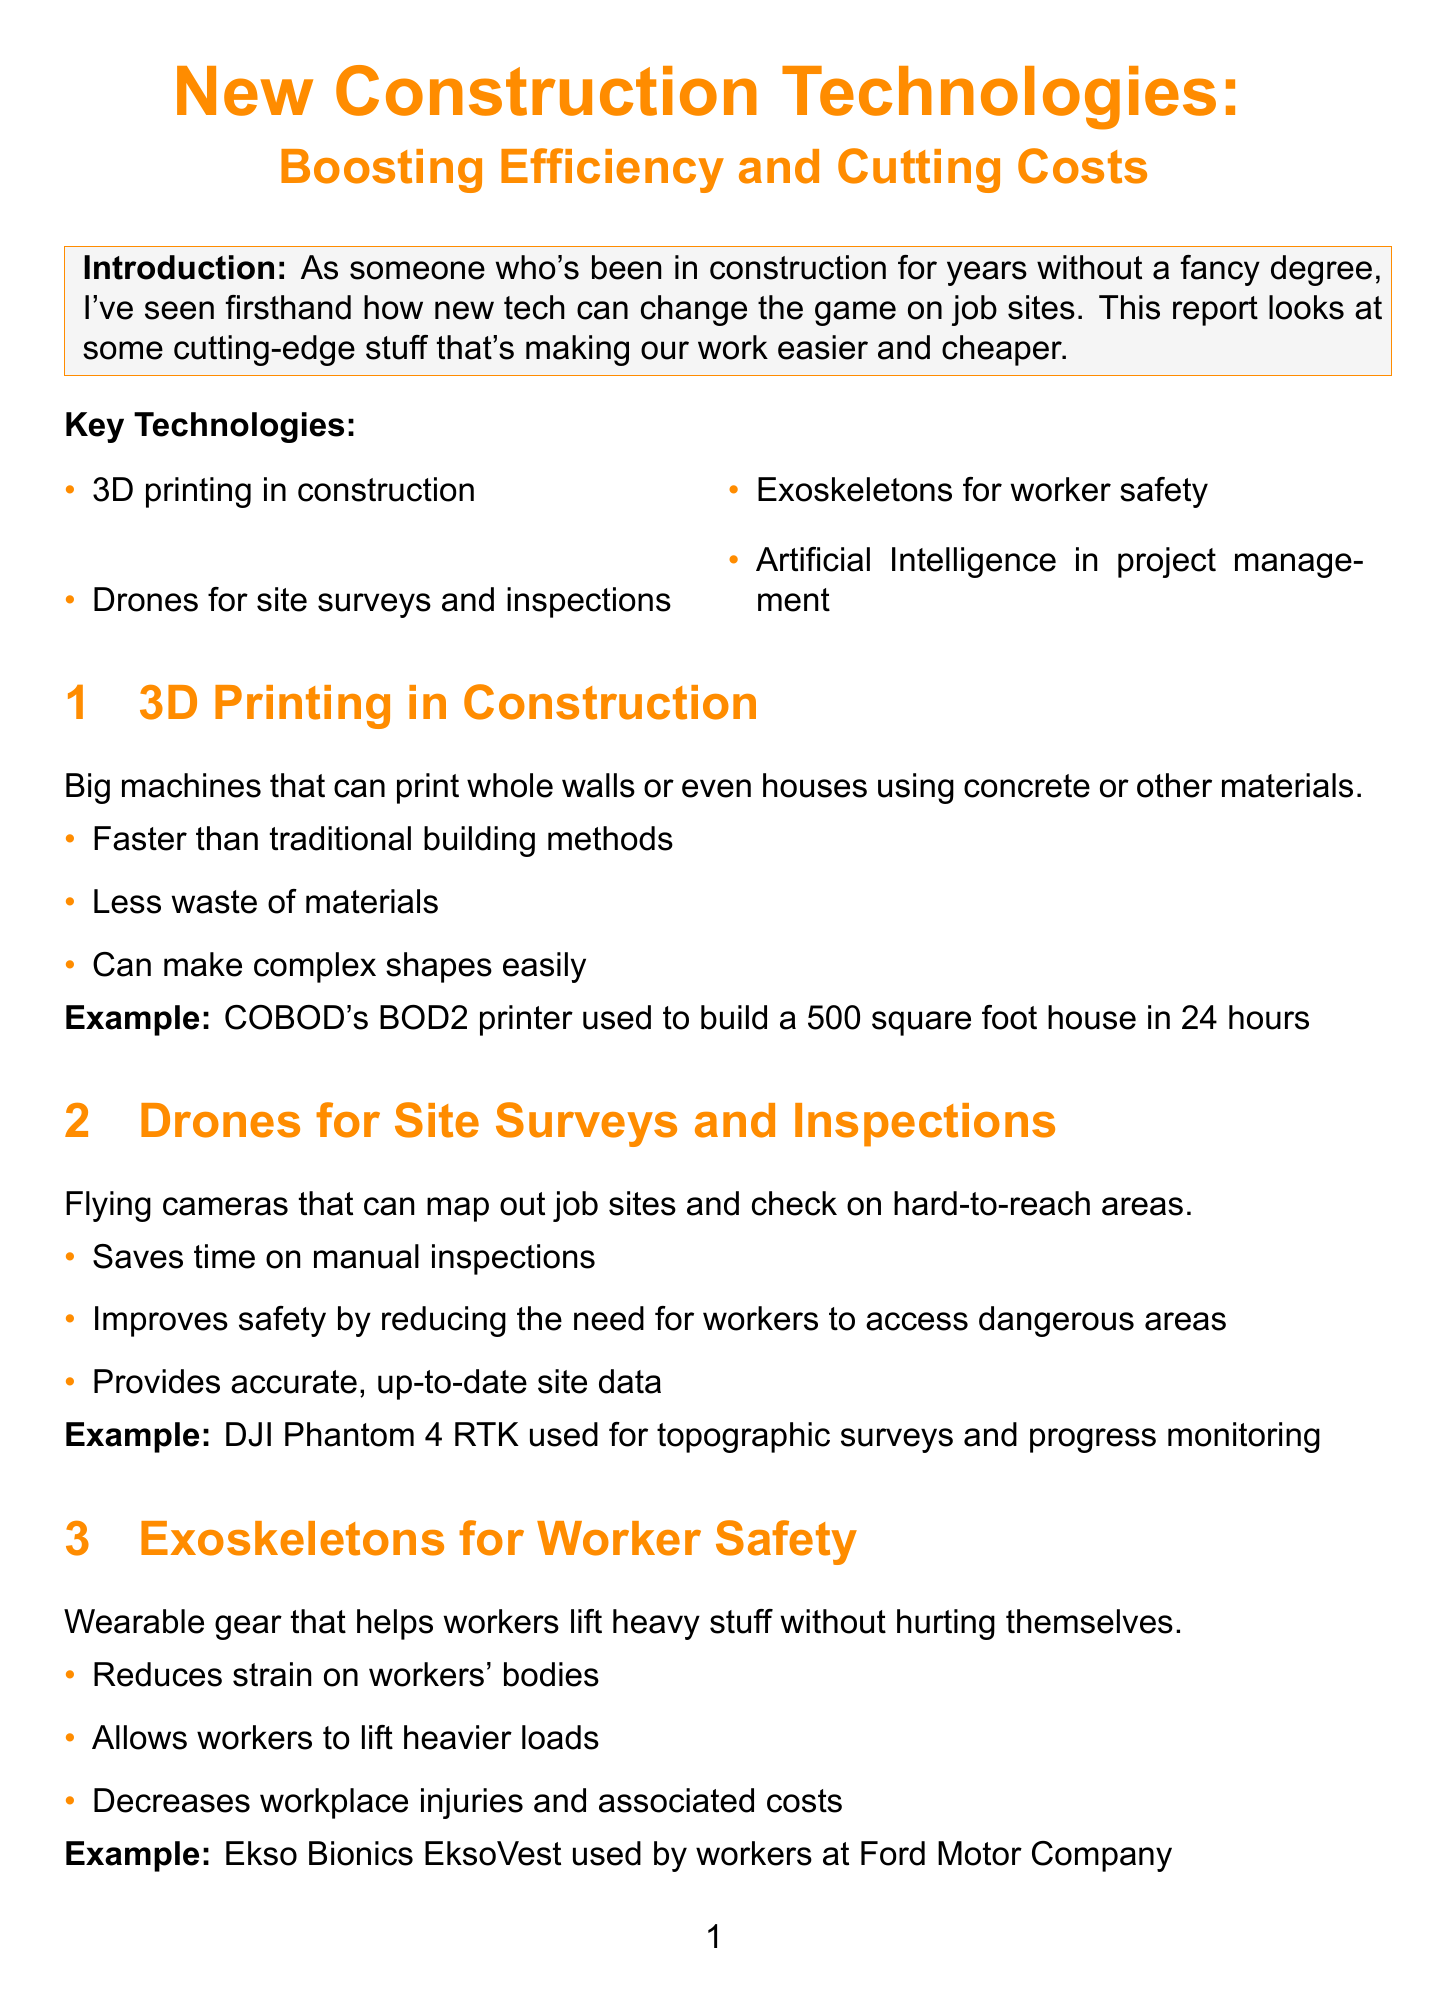What are the key points discussed in the report? The report lists four key points: 3D printing in construction, drones for site surveys and inspections, exoskeletons for worker safety, and artificial intelligence in project management.
Answer: 3D printing in construction; drones for site surveys and inspections; exoskeletons for worker safety; artificial intelligence in project management What technology can cut labor needs by up to 30%? The report states that the technologies discussed can cut labor needs on projects by up to 30%.
Answer: Technologies What is one benefit of using drones on job sites? The document mentions that drones improve safety by reducing the need for workers to access dangerous areas.
Answer: Improves safety What is the example given for 3D printing technology? The report provides COBOD's BOD2 printer used to build a 500 square foot house in 24 hours as an example.
Answer: COBOD's BOD2 printer What wearable gear helps reduce worker injuries? The report refers to exoskeletons as wearable gear that helps workers lift heavy stuff without hurting themselves.
Answer: Exoskeletons What are some challenges faced when adopting new construction technologies? The report lists four challenges: high upfront costs for new equipment, need for training to use new tech, resistance from old-school workers, and concerns about job losses due to automation.
Answer: High upfront costs; need for training; resistance from old-school workers; concerns about job losses How do these technologies impact project timelines? The document states that jobs that used to take months might now only take weeks due to these technologies.
Answer: Only take weeks What future outlook does the report provide on construction jobs? The conclusion mentions that construction jobs might change but won't disappear, as there will be a need for people who understand both hands-on work and new tools.
Answer: Won't disappear 